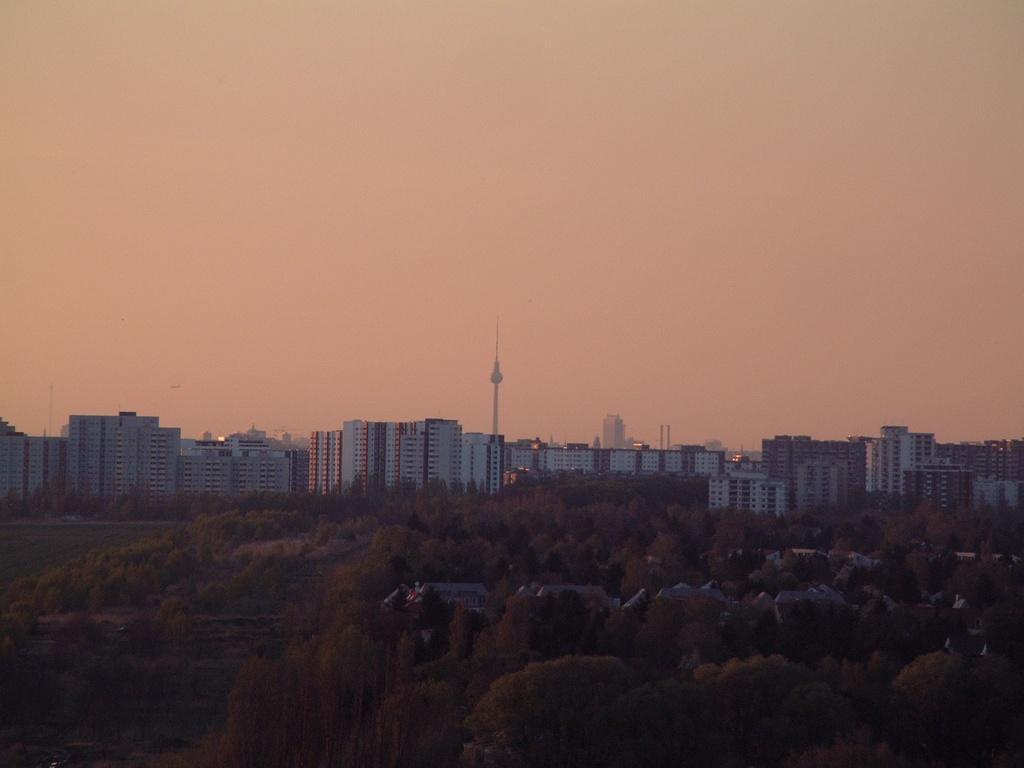Describe this image in one or two sentences. At the bottom of the picture, we see trees. There are trees and buildings in the background. At the top of the picture, we see the sky. We even see a tower in the background. 